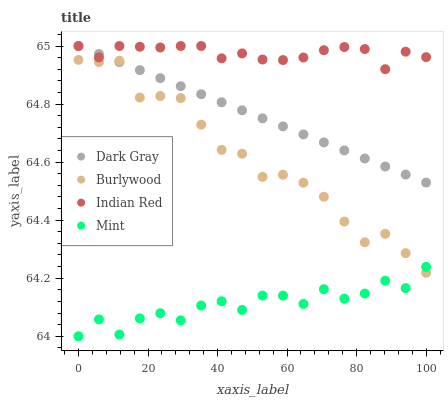Does Mint have the minimum area under the curve?
Answer yes or no. Yes. Does Indian Red have the maximum area under the curve?
Answer yes or no. Yes. Does Burlywood have the minimum area under the curve?
Answer yes or no. No. Does Burlywood have the maximum area under the curve?
Answer yes or no. No. Is Dark Gray the smoothest?
Answer yes or no. Yes. Is Mint the roughest?
Answer yes or no. Yes. Is Burlywood the smoothest?
Answer yes or no. No. Is Burlywood the roughest?
Answer yes or no. No. Does Mint have the lowest value?
Answer yes or no. Yes. Does Burlywood have the lowest value?
Answer yes or no. No. Does Indian Red have the highest value?
Answer yes or no. Yes. Does Burlywood have the highest value?
Answer yes or no. No. Is Mint less than Dark Gray?
Answer yes or no. Yes. Is Indian Red greater than Mint?
Answer yes or no. Yes. Does Dark Gray intersect Indian Red?
Answer yes or no. Yes. Is Dark Gray less than Indian Red?
Answer yes or no. No. Is Dark Gray greater than Indian Red?
Answer yes or no. No. Does Mint intersect Dark Gray?
Answer yes or no. No. 